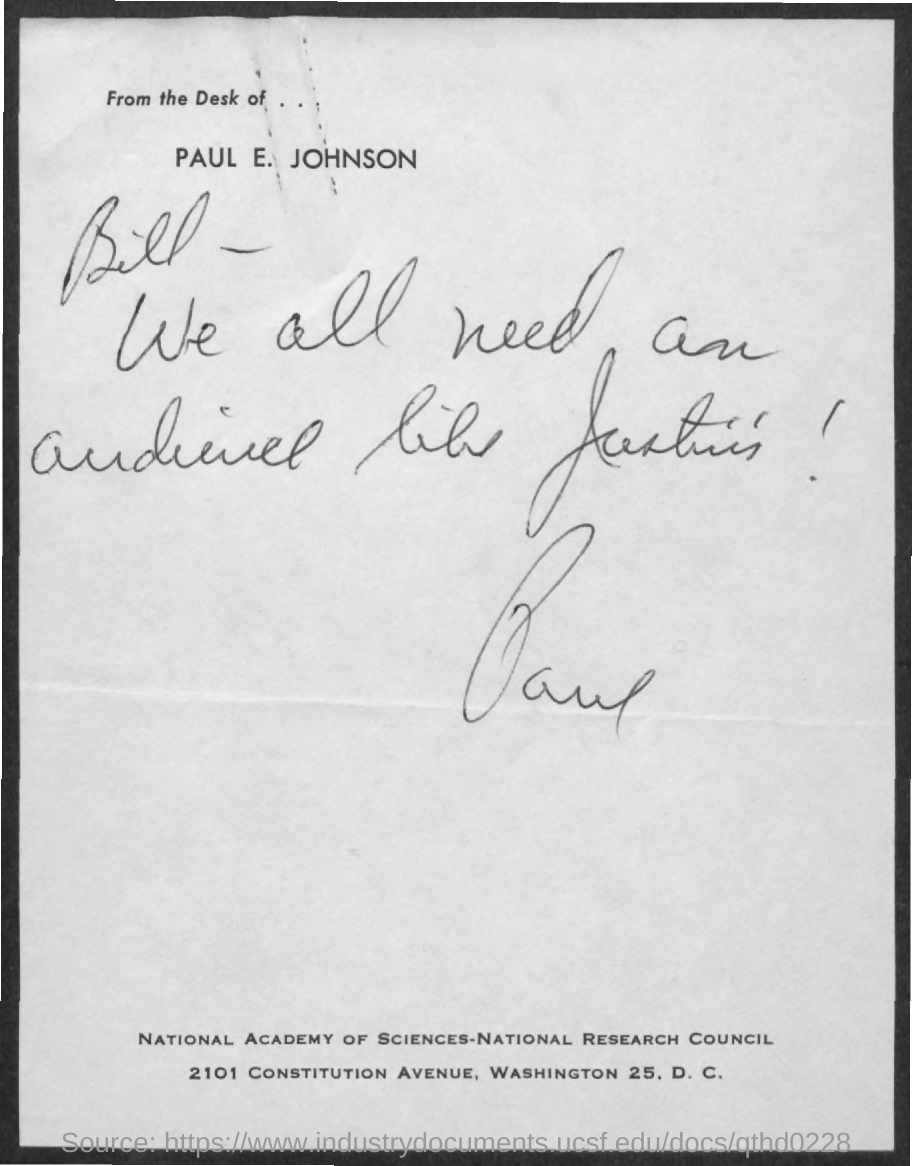Identify some key points in this picture. The note is addressed to Bill. 